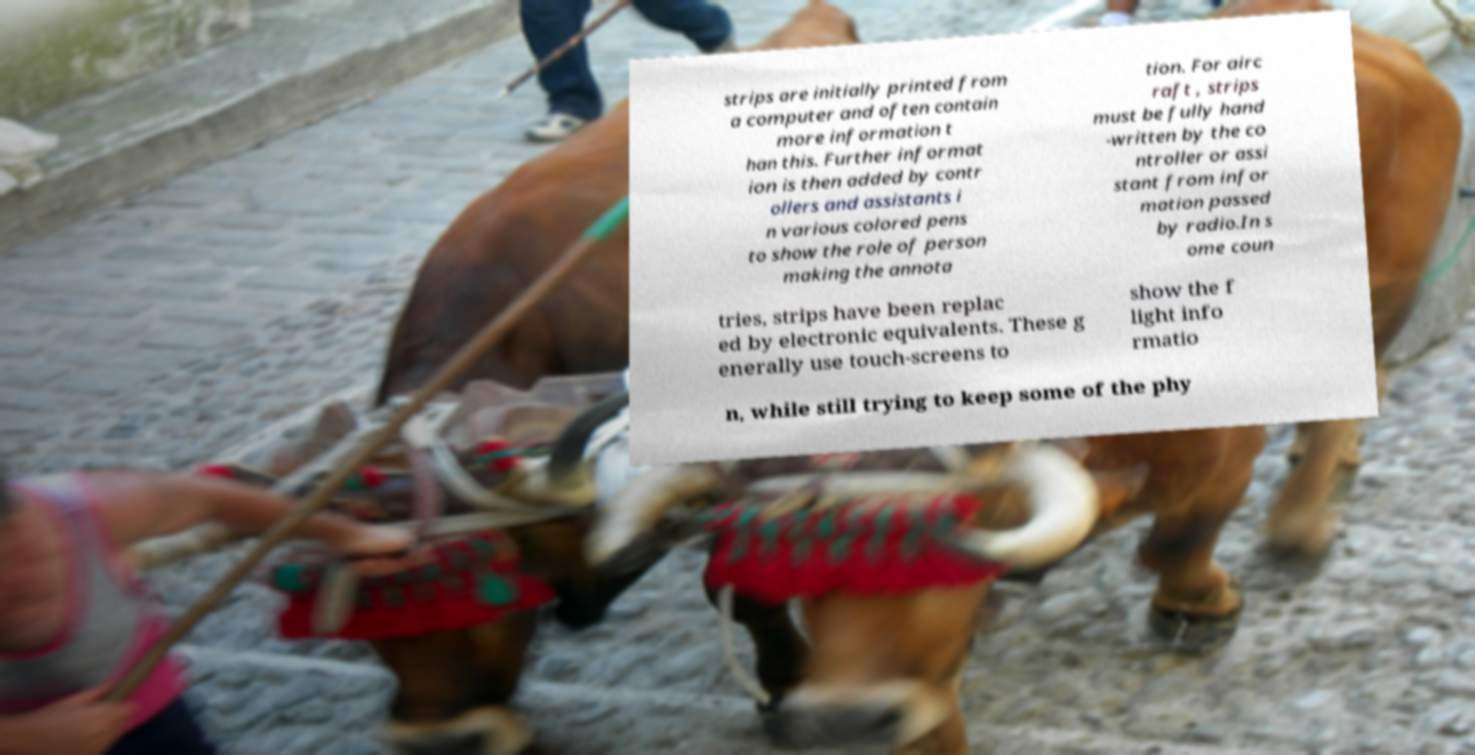Can you read and provide the text displayed in the image?This photo seems to have some interesting text. Can you extract and type it out for me? strips are initially printed from a computer and often contain more information t han this. Further informat ion is then added by contr ollers and assistants i n various colored pens to show the role of person making the annota tion. For airc raft , strips must be fully hand -written by the co ntroller or assi stant from infor mation passed by radio.In s ome coun tries, strips have been replac ed by electronic equivalents. These g enerally use touch-screens to show the f light info rmatio n, while still trying to keep some of the phy 